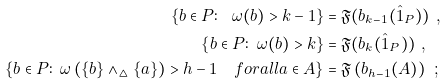<formula> <loc_0><loc_0><loc_500><loc_500>\left \{ b \in P \colon \ \omega ( b ) > k - 1 \right \} & = \mathfrak { F } ( b _ { k - 1 } ( \hat { 1 } _ { P } ) ) \ , \\ \left \{ b \in P \colon \ \omega ( b ) > k \right \} & = \mathfrak { F } ( b _ { k } ( \hat { 1 } _ { P } ) ) \ , \\ \left \{ b \in P \colon \ \omega \left ( \{ b \} \wedge _ { \vartriangle } \{ a \} \right ) > h - 1 \quad f o r a l l a \in A \right \} & = \mathfrak { F } \left ( b _ { h - 1 } ( A ) \right ) \ ;</formula> 